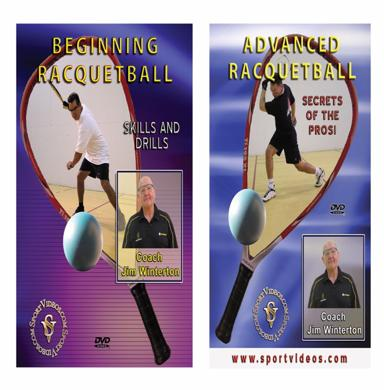What is the image promoting?
 The image is promoting instructional DVDs on racquetball, featuring lessons from coaches Jim Winterton and Coach DVD Jim Winterton. What levels of racquetball instruction are offered in the DVDs mentioned in the image? There are two levels of instruction offered: "Beginning Racquetball" and "Advanced Racquetball." The advanced level also includes "Secrets of the Pros: Skills and Drills." 